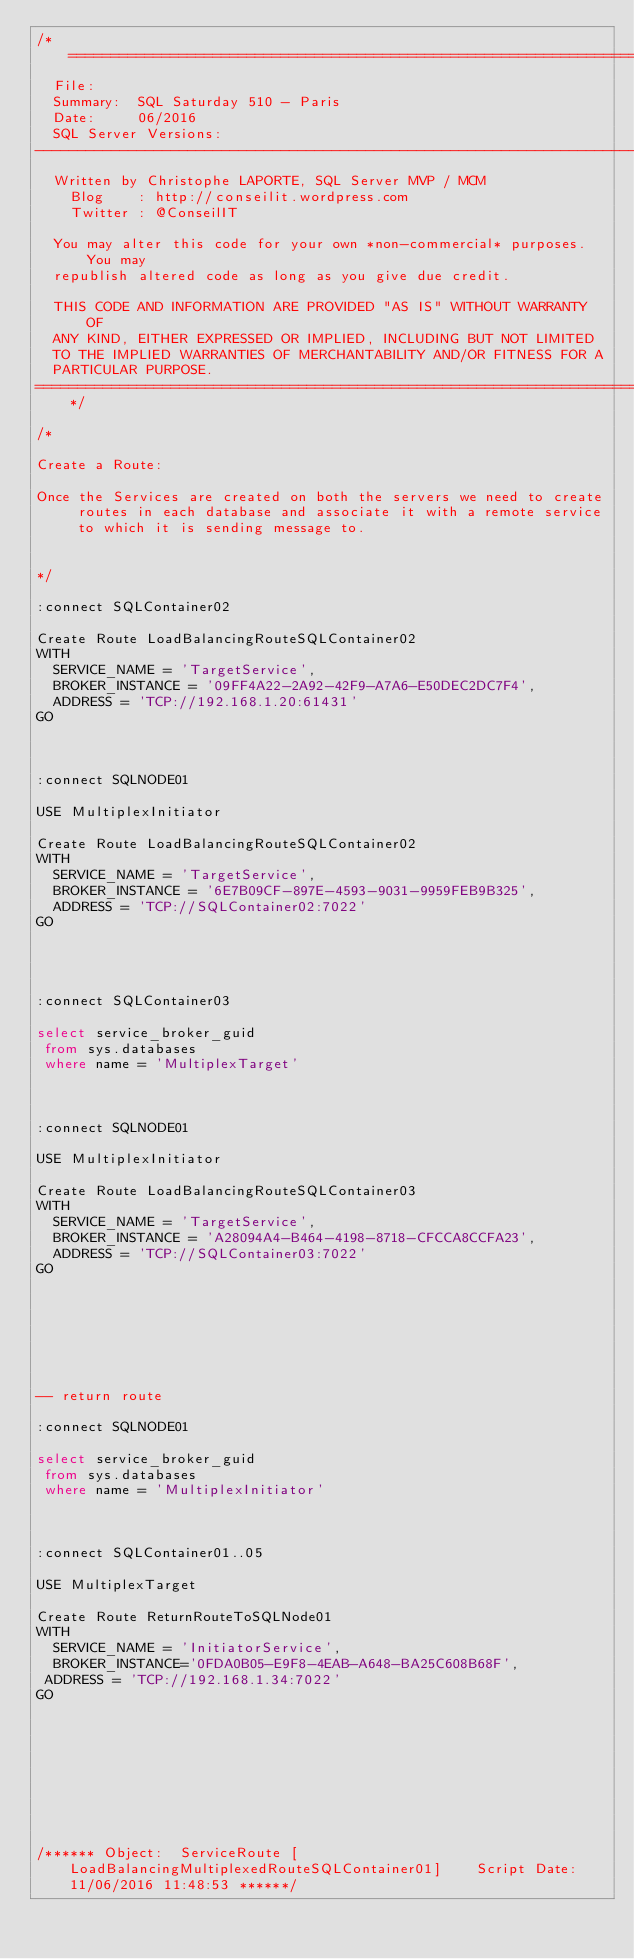Convert code to text. <code><loc_0><loc_0><loc_500><loc_500><_SQL_>/*============================================================================
  File:     
  Summary:  SQL Saturday 510 - Paris
  Date:     06/2016
  SQL Server Versions: 
------------------------------------------------------------------------------
  Written by Christophe LAPORTE, SQL Server MVP / MCM
	Blog    : http://conseilit.wordpress.com
	Twitter : @ConseilIT
  
  You may alter this code for your own *non-commercial* purposes. You may
  republish altered code as long as you give due credit.
  
  THIS CODE AND INFORMATION ARE PROVIDED "AS IS" WITHOUT WARRANTY OF 
  ANY KIND, EITHER EXPRESSED OR IMPLIED, INCLUDING BUT NOT LIMITED 
  TO THE IMPLIED WARRANTIES OF MERCHANTABILITY AND/OR FITNESS FOR A
  PARTICULAR PURPOSE.
============================================================================*/

/*

Create a Route:

Once the Services are created on both the servers we need to create routes in each database and associate it with a remote service to which it is sending message to.


*/

:connect SQLContainer02

Create Route LoadBalancingRouteSQLContainer02
WITH
  SERVICE_NAME = 'TargetService',
  BROKER_INSTANCE = '09FF4A22-2A92-42F9-A7A6-E50DEC2DC7F4',
  ADDRESS = 'TCP://192.168.1.20:61431'
GO



:connect SQLNODE01

USE MultiplexInitiator

Create Route LoadBalancingRouteSQLContainer02
WITH
  SERVICE_NAME = 'TargetService',
  BROKER_INSTANCE = '6E7B09CF-897E-4593-9031-9959FEB9B325',
  ADDRESS = 'TCP://SQLContainer02:7022'
GO

 

 
:connect SQLContainer03

select service_broker_guid
 from sys.databases
 where name = 'MultiplexTarget'



:connect SQLNODE01

USE MultiplexInitiator

Create Route LoadBalancingRouteSQLContainer03
WITH
  SERVICE_NAME = 'TargetService',
  BROKER_INSTANCE = 'A28094A4-B464-4198-8718-CFCCA8CCFA23',
  ADDRESS = 'TCP://SQLContainer03:7022'
GO

 

 

 
 
-- return route

:connect SQLNODE01

select service_broker_guid
 from sys.databases
 where name = 'MultiplexInitiator'



:connect SQLContainer01..05

USE MultiplexTarget

Create Route ReturnRouteToSQLNode01
WITH
  SERVICE_NAME = 'InitiatorService',
  BROKER_INSTANCE='0FDA0B05-E9F8-4EAB-A648-BA25C608B68F',
 ADDRESS = 'TCP://192.168.1.34:7022'
GO

 

 





/****** Object:  ServiceRoute [LoadBalancingMultiplexedRouteSQLContainer01]    Script Date: 11/06/2016 11:48:53 ******/</code> 